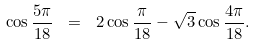Convert formula to latex. <formula><loc_0><loc_0><loc_500><loc_500>\cos \frac { 5 \pi } { 1 8 } \ = \ 2 \cos \frac { \pi } { 1 8 } - \sqrt { 3 } \cos \frac { 4 \pi } { 1 8 } .</formula> 